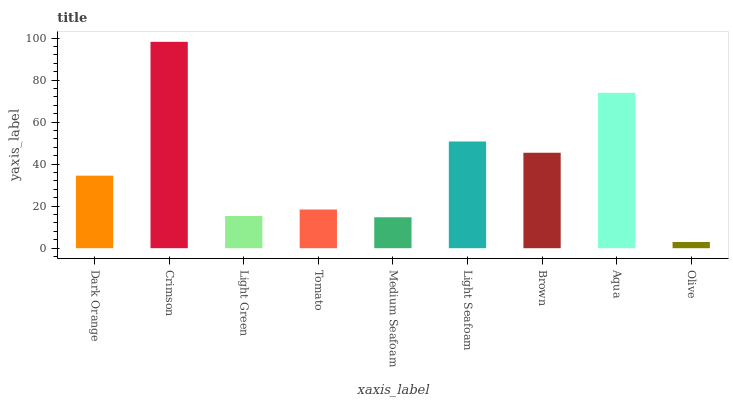Is Olive the minimum?
Answer yes or no. Yes. Is Crimson the maximum?
Answer yes or no. Yes. Is Light Green the minimum?
Answer yes or no. No. Is Light Green the maximum?
Answer yes or no. No. Is Crimson greater than Light Green?
Answer yes or no. Yes. Is Light Green less than Crimson?
Answer yes or no. Yes. Is Light Green greater than Crimson?
Answer yes or no. No. Is Crimson less than Light Green?
Answer yes or no. No. Is Dark Orange the high median?
Answer yes or no. Yes. Is Dark Orange the low median?
Answer yes or no. Yes. Is Brown the high median?
Answer yes or no. No. Is Aqua the low median?
Answer yes or no. No. 